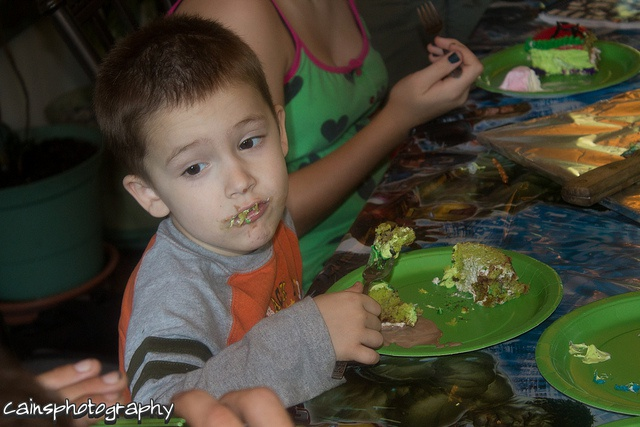Describe the objects in this image and their specific colors. I can see dining table in black, darkgreen, and gray tones, people in black, gray, and darkgray tones, people in black, maroon, and darkgreen tones, potted plant in black tones, and cake in black and olive tones in this image. 